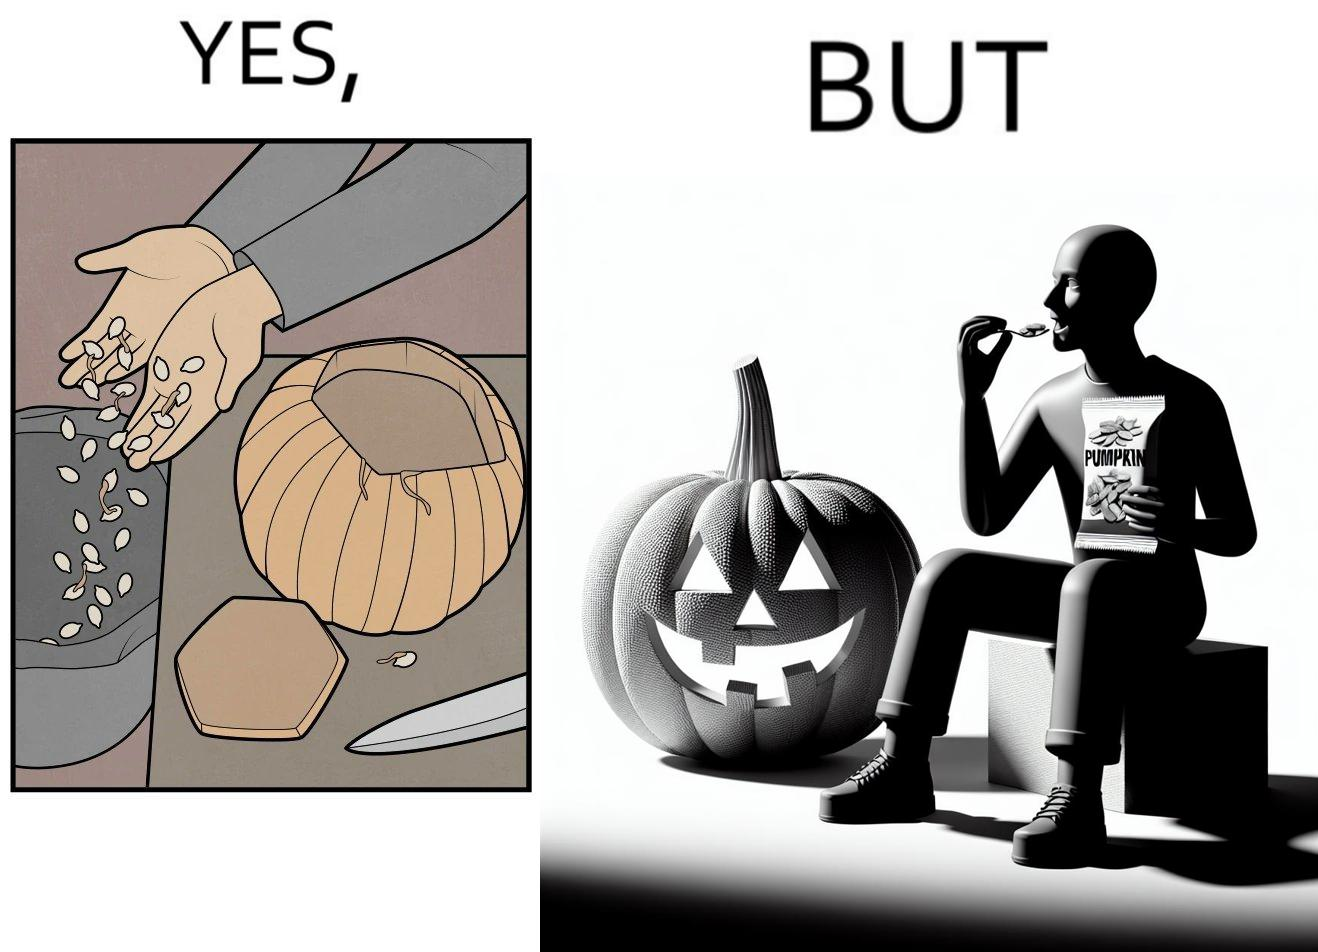What makes this image funny or satirical? The image is ironic, because on one side the same person throws pumpkin seeds out of pumpkin into dustbin when brought at home but he is eating the package pumpkin seeds 